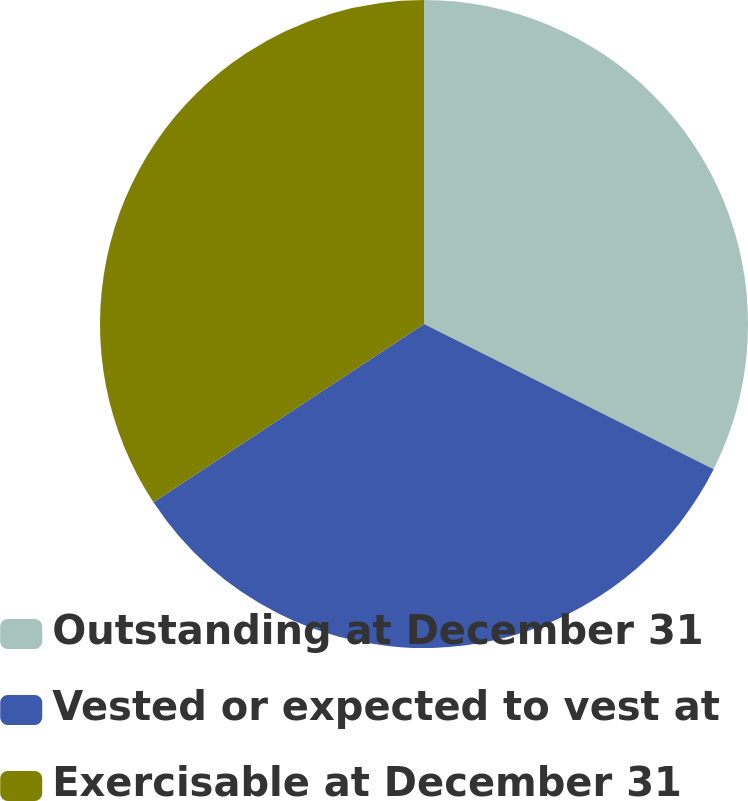Convert chart to OTSL. <chart><loc_0><loc_0><loc_500><loc_500><pie_chart><fcel>Outstanding at December 31<fcel>Vested or expected to vest at<fcel>Exercisable at December 31<nl><fcel>32.39%<fcel>33.33%<fcel>34.27%<nl></chart> 